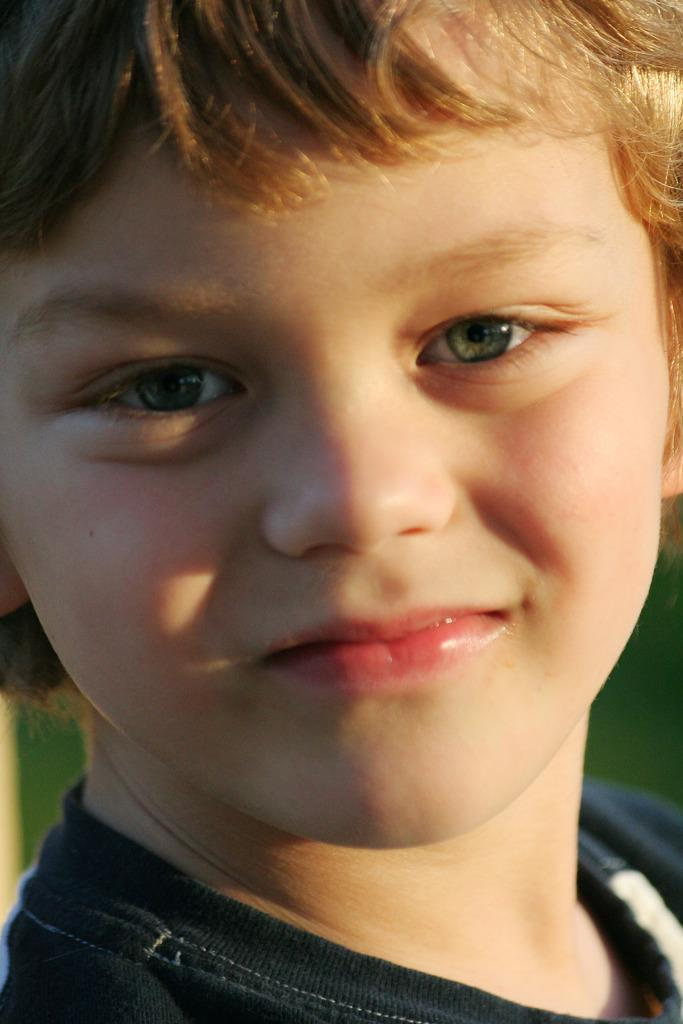What is the main subject of the image? There is a child's face in the image. What is the child wearing in the image? The child is wearing a black colored dress. What color is the background of the image? The background of the image is green. How many beans are on the child's head in the image? There are no beans present in the image; it only features the child's face and a green background. 